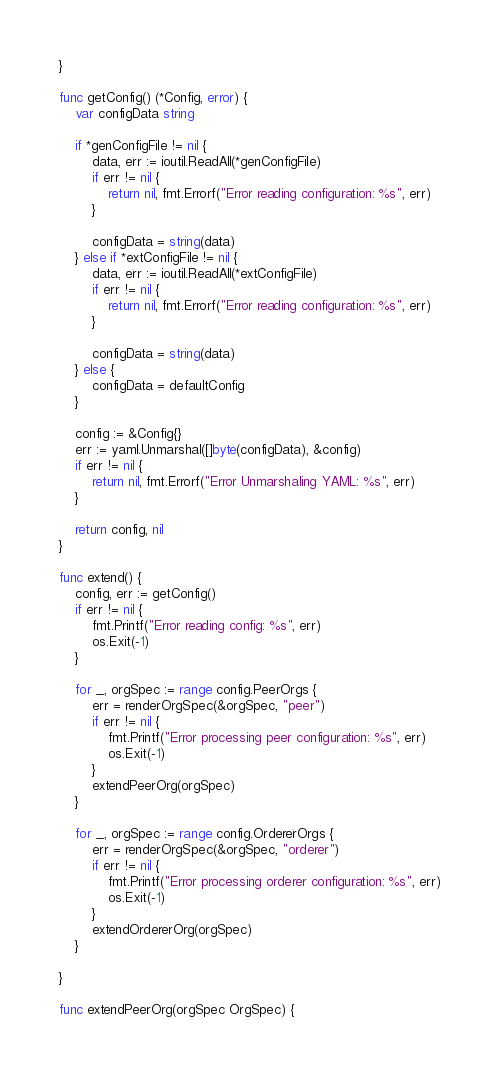Convert code to text. <code><loc_0><loc_0><loc_500><loc_500><_Go_>}

func getConfig() (*Config, error) {
	var configData string

	if *genConfigFile != nil {
		data, err := ioutil.ReadAll(*genConfigFile)
		if err != nil {
			return nil, fmt.Errorf("Error reading configuration: %s", err)
		}

		configData = string(data)
	} else if *extConfigFile != nil {
		data, err := ioutil.ReadAll(*extConfigFile)
		if err != nil {
			return nil, fmt.Errorf("Error reading configuration: %s", err)
		}

		configData = string(data)
	} else {
		configData = defaultConfig
	}

	config := &Config{}
	err := yaml.Unmarshal([]byte(configData), &config)
	if err != nil {
		return nil, fmt.Errorf("Error Unmarshaling YAML: %s", err)
	}

	return config, nil
}

func extend() {
	config, err := getConfig()
	if err != nil {
		fmt.Printf("Error reading config: %s", err)
		os.Exit(-1)
	}

	for _, orgSpec := range config.PeerOrgs {
		err = renderOrgSpec(&orgSpec, "peer")
		if err != nil {
			fmt.Printf("Error processing peer configuration: %s", err)
			os.Exit(-1)
		}
		extendPeerOrg(orgSpec)
	}

	for _, orgSpec := range config.OrdererOrgs {
		err = renderOrgSpec(&orgSpec, "orderer")
		if err != nil {
			fmt.Printf("Error processing orderer configuration: %s", err)
			os.Exit(-1)
		}
		extendOrdererOrg(orgSpec)
	}

}

func extendPeerOrg(orgSpec OrgSpec) {</code> 